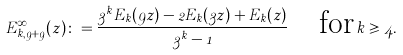<formula> <loc_0><loc_0><loc_500><loc_500>E _ { k , 9 + 9 } ^ { \infty } ( z ) \colon = \frac { 3 ^ { k } E _ { k } ( 9 z ) - 2 E _ { k } ( 3 z ) + E _ { k } ( z ) } { 3 ^ { k } - 1 } \quad \text {for} \, k \geqslant 4 .</formula> 